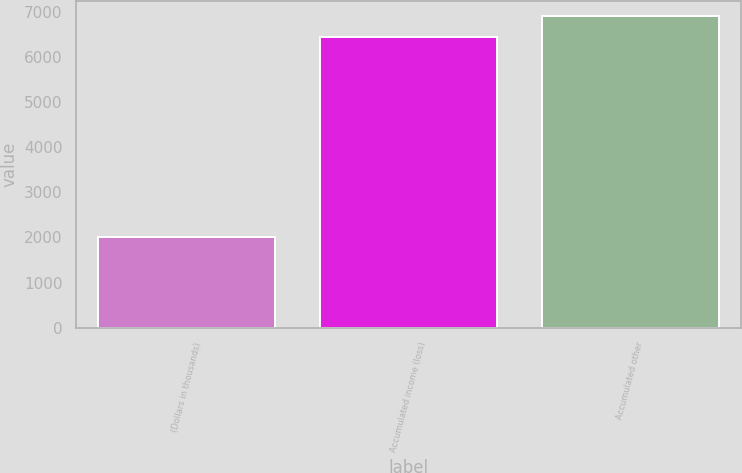<chart> <loc_0><loc_0><loc_500><loc_500><bar_chart><fcel>(Dollars in thousands)<fcel>Accumulated income (loss)<fcel>Accumulated other<nl><fcel>2013<fcel>6452<fcel>6895.9<nl></chart> 